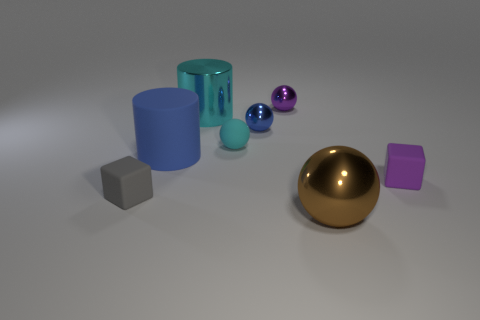Subtract all metallic spheres. How many spheres are left? 1 Subtract 1 spheres. How many spheres are left? 3 Subtract all red spheres. Subtract all red cylinders. How many spheres are left? 4 Add 1 big brown metal objects. How many objects exist? 9 Subtract all cylinders. How many objects are left? 6 Subtract all large brown objects. Subtract all blue rubber objects. How many objects are left? 6 Add 8 blue spheres. How many blue spheres are left? 9 Add 4 tiny blue matte balls. How many tiny blue matte balls exist? 4 Subtract 1 cyan cylinders. How many objects are left? 7 